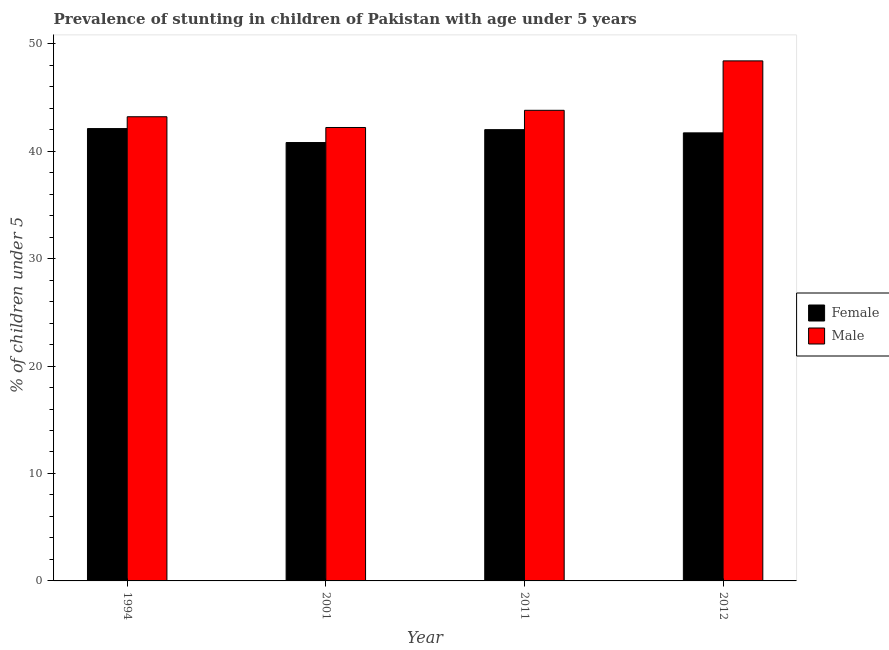How many bars are there on the 4th tick from the left?
Offer a terse response. 2. What is the percentage of stunted male children in 2001?
Ensure brevity in your answer.  42.2. Across all years, what is the maximum percentage of stunted female children?
Keep it short and to the point. 42.1. Across all years, what is the minimum percentage of stunted male children?
Offer a terse response. 42.2. What is the total percentage of stunted female children in the graph?
Ensure brevity in your answer.  166.6. What is the difference between the percentage of stunted female children in 2001 and that in 2012?
Your answer should be very brief. -0.9. What is the difference between the percentage of stunted male children in 2011 and the percentage of stunted female children in 2012?
Your answer should be compact. -4.6. What is the average percentage of stunted male children per year?
Your answer should be compact. 44.4. What is the ratio of the percentage of stunted male children in 1994 to that in 2001?
Your answer should be compact. 1.02. Is the percentage of stunted male children in 2001 less than that in 2011?
Your answer should be very brief. Yes. Is the difference between the percentage of stunted male children in 2001 and 2012 greater than the difference between the percentage of stunted female children in 2001 and 2012?
Your response must be concise. No. What is the difference between the highest and the second highest percentage of stunted male children?
Your answer should be very brief. 4.6. What is the difference between the highest and the lowest percentage of stunted male children?
Ensure brevity in your answer.  6.2. In how many years, is the percentage of stunted male children greater than the average percentage of stunted male children taken over all years?
Make the answer very short. 1. Is the sum of the percentage of stunted female children in 2001 and 2011 greater than the maximum percentage of stunted male children across all years?
Provide a short and direct response. Yes. What does the 1st bar from the right in 2011 represents?
Your response must be concise. Male. Are the values on the major ticks of Y-axis written in scientific E-notation?
Ensure brevity in your answer.  No. Does the graph contain any zero values?
Your answer should be compact. No. Does the graph contain grids?
Offer a very short reply. No. How many legend labels are there?
Your answer should be compact. 2. How are the legend labels stacked?
Your response must be concise. Vertical. What is the title of the graph?
Make the answer very short. Prevalence of stunting in children of Pakistan with age under 5 years. What is the label or title of the Y-axis?
Keep it short and to the point.  % of children under 5. What is the  % of children under 5 in Female in 1994?
Give a very brief answer. 42.1. What is the  % of children under 5 in Male in 1994?
Ensure brevity in your answer.  43.2. What is the  % of children under 5 of Female in 2001?
Give a very brief answer. 40.8. What is the  % of children under 5 in Male in 2001?
Your answer should be compact. 42.2. What is the  % of children under 5 in Female in 2011?
Give a very brief answer. 42. What is the  % of children under 5 of Male in 2011?
Provide a succinct answer. 43.8. What is the  % of children under 5 in Female in 2012?
Make the answer very short. 41.7. What is the  % of children under 5 of Male in 2012?
Your response must be concise. 48.4. Across all years, what is the maximum  % of children under 5 of Female?
Ensure brevity in your answer.  42.1. Across all years, what is the maximum  % of children under 5 in Male?
Your response must be concise. 48.4. Across all years, what is the minimum  % of children under 5 in Female?
Your response must be concise. 40.8. Across all years, what is the minimum  % of children under 5 of Male?
Offer a terse response. 42.2. What is the total  % of children under 5 in Female in the graph?
Your answer should be very brief. 166.6. What is the total  % of children under 5 of Male in the graph?
Your answer should be compact. 177.6. What is the difference between the  % of children under 5 in Male in 1994 and that in 2011?
Offer a terse response. -0.6. What is the difference between the  % of children under 5 of Female in 2001 and that in 2012?
Keep it short and to the point. -0.9. What is the difference between the  % of children under 5 in Male in 2001 and that in 2012?
Provide a short and direct response. -6.2. What is the difference between the  % of children under 5 in Female in 1994 and the  % of children under 5 in Male in 2011?
Make the answer very short. -1.7. What is the difference between the  % of children under 5 of Female in 1994 and the  % of children under 5 of Male in 2012?
Give a very brief answer. -6.3. What is the difference between the  % of children under 5 in Female in 2011 and the  % of children under 5 in Male in 2012?
Provide a short and direct response. -6.4. What is the average  % of children under 5 in Female per year?
Provide a succinct answer. 41.65. What is the average  % of children under 5 in Male per year?
Offer a terse response. 44.4. In the year 1994, what is the difference between the  % of children under 5 of Female and  % of children under 5 of Male?
Provide a succinct answer. -1.1. In the year 2001, what is the difference between the  % of children under 5 of Female and  % of children under 5 of Male?
Offer a terse response. -1.4. In the year 2011, what is the difference between the  % of children under 5 of Female and  % of children under 5 of Male?
Provide a succinct answer. -1.8. What is the ratio of the  % of children under 5 in Female in 1994 to that in 2001?
Provide a short and direct response. 1.03. What is the ratio of the  % of children under 5 of Male in 1994 to that in 2001?
Ensure brevity in your answer.  1.02. What is the ratio of the  % of children under 5 of Male in 1994 to that in 2011?
Provide a succinct answer. 0.99. What is the ratio of the  % of children under 5 of Female in 1994 to that in 2012?
Your answer should be compact. 1.01. What is the ratio of the  % of children under 5 of Male in 1994 to that in 2012?
Your answer should be compact. 0.89. What is the ratio of the  % of children under 5 of Female in 2001 to that in 2011?
Make the answer very short. 0.97. What is the ratio of the  % of children under 5 of Male in 2001 to that in 2011?
Provide a succinct answer. 0.96. What is the ratio of the  % of children under 5 in Female in 2001 to that in 2012?
Ensure brevity in your answer.  0.98. What is the ratio of the  % of children under 5 of Male in 2001 to that in 2012?
Keep it short and to the point. 0.87. What is the ratio of the  % of children under 5 of Female in 2011 to that in 2012?
Make the answer very short. 1.01. What is the ratio of the  % of children under 5 of Male in 2011 to that in 2012?
Provide a short and direct response. 0.91. What is the difference between the highest and the second highest  % of children under 5 in Male?
Keep it short and to the point. 4.6. What is the difference between the highest and the lowest  % of children under 5 in Male?
Provide a short and direct response. 6.2. 